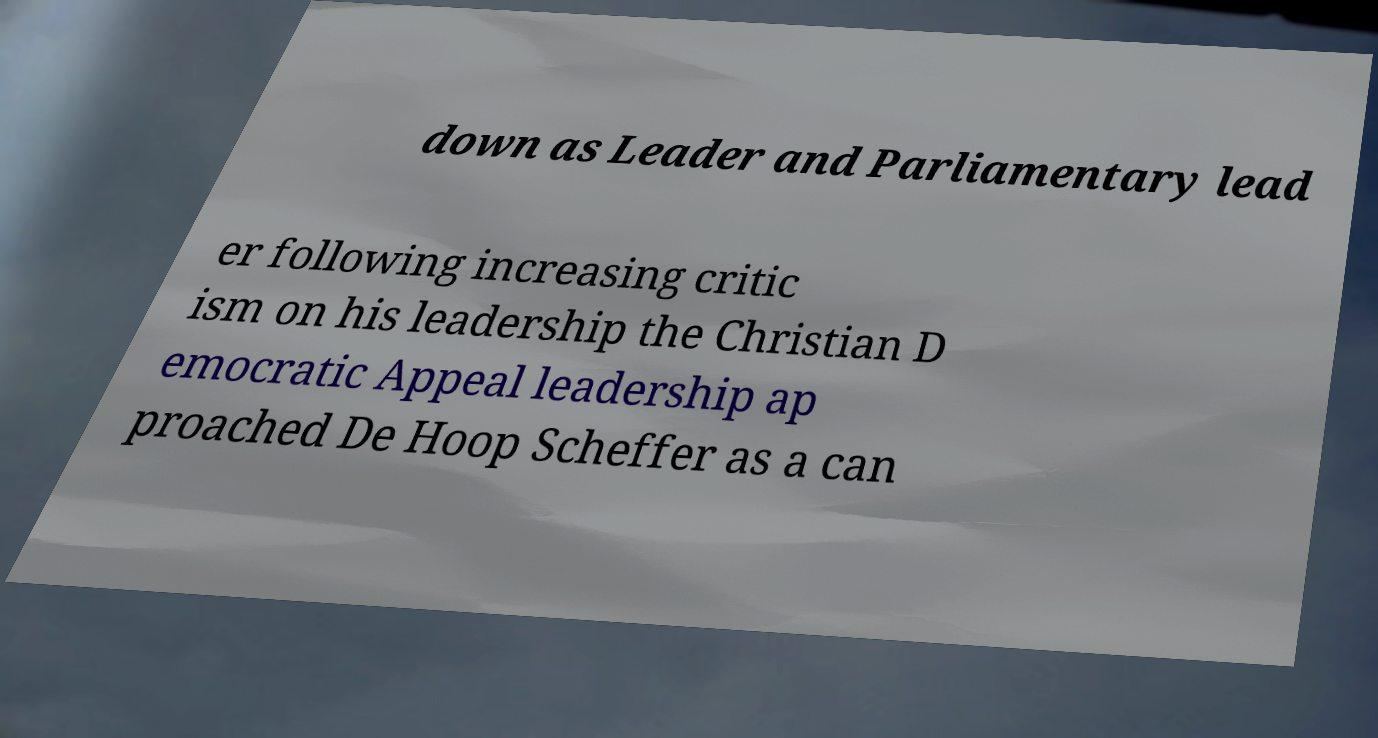Can you read and provide the text displayed in the image?This photo seems to have some interesting text. Can you extract and type it out for me? down as Leader and Parliamentary lead er following increasing critic ism on his leadership the Christian D emocratic Appeal leadership ap proached De Hoop Scheffer as a can 